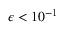<formula> <loc_0><loc_0><loc_500><loc_500>\epsilon < 1 0 ^ { - 1 }</formula> 